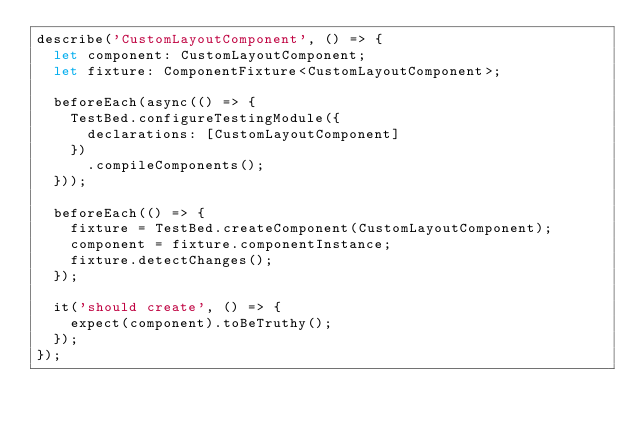<code> <loc_0><loc_0><loc_500><loc_500><_TypeScript_>describe('CustomLayoutComponent', () => {
  let component: CustomLayoutComponent;
  let fixture: ComponentFixture<CustomLayoutComponent>;

  beforeEach(async(() => {
    TestBed.configureTestingModule({
      declarations: [CustomLayoutComponent]
    })
      .compileComponents();
  }));

  beforeEach(() => {
    fixture = TestBed.createComponent(CustomLayoutComponent);
    component = fixture.componentInstance;
    fixture.detectChanges();
  });

  it('should create', () => {
    expect(component).toBeTruthy();
  });
});
</code> 